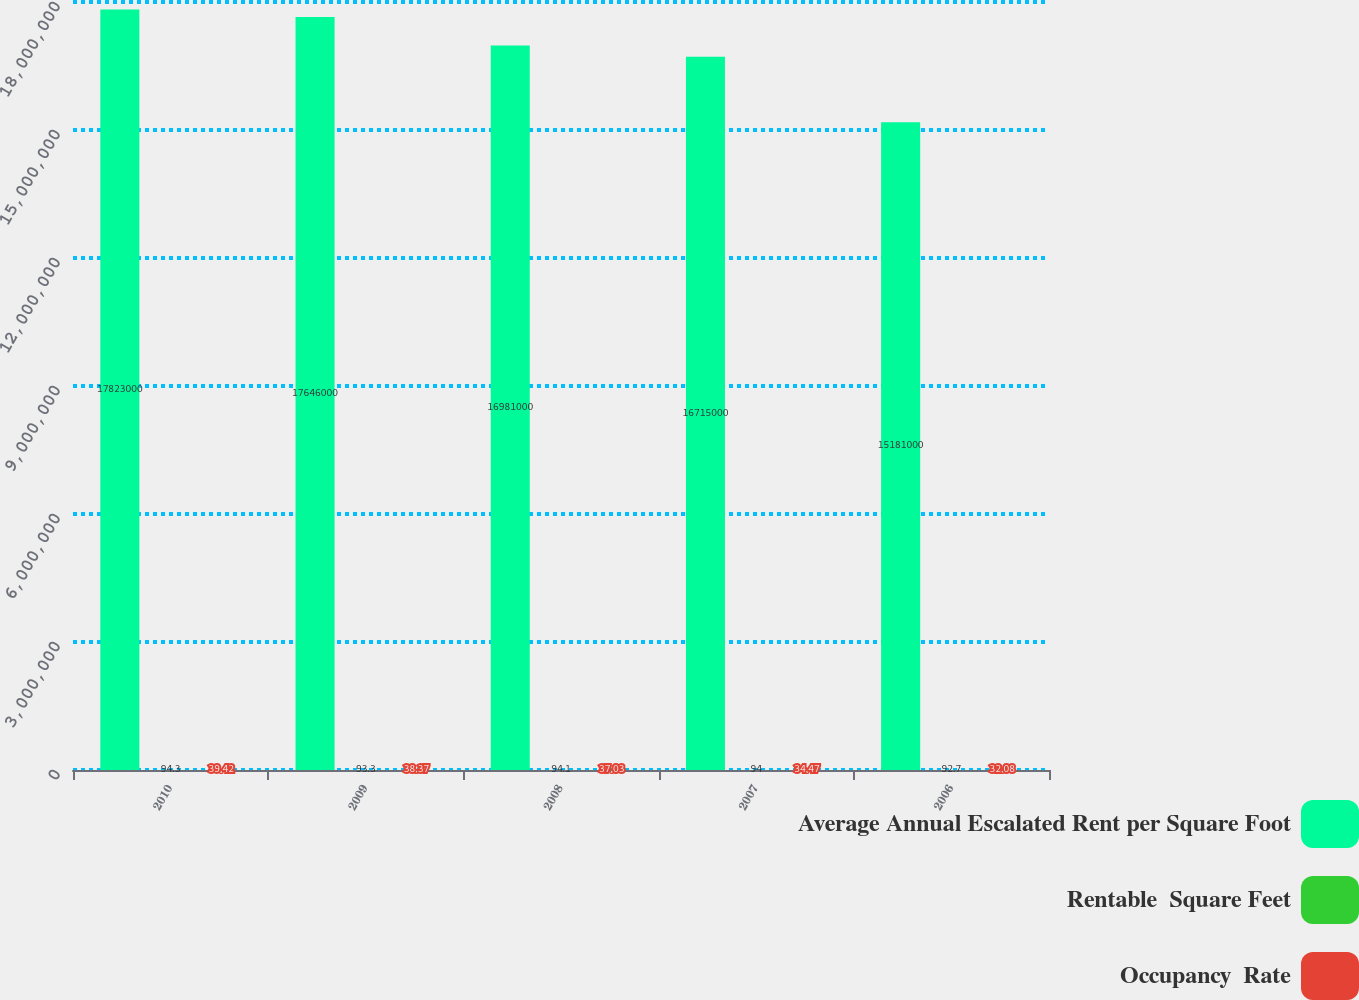Convert chart to OTSL. <chart><loc_0><loc_0><loc_500><loc_500><stacked_bar_chart><ecel><fcel>2010<fcel>2009<fcel>2008<fcel>2007<fcel>2006<nl><fcel>Average Annual Escalated Rent per Square Foot<fcel>1.7823e+07<fcel>1.7646e+07<fcel>1.6981e+07<fcel>1.6715e+07<fcel>1.5181e+07<nl><fcel>Rentable  Square Feet<fcel>94.3<fcel>93.3<fcel>94.1<fcel>94<fcel>92.7<nl><fcel>Occupancy  Rate<fcel>39.42<fcel>38.37<fcel>37.03<fcel>34.47<fcel>32.08<nl></chart> 